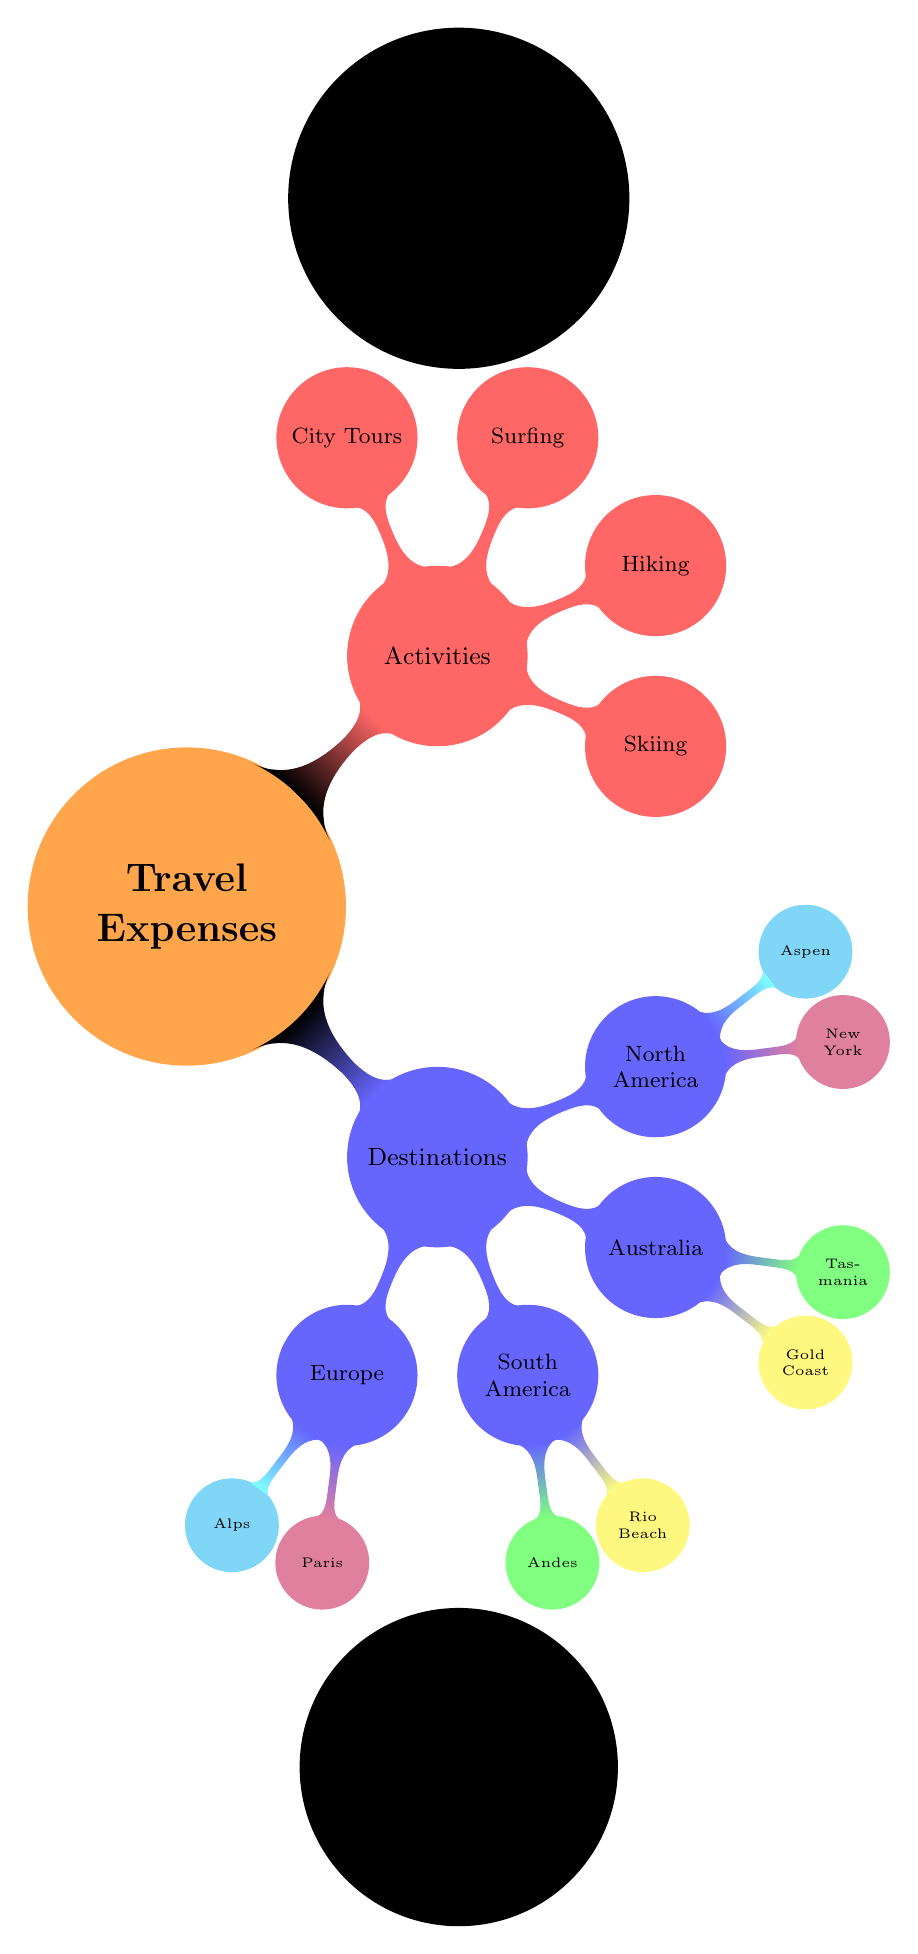What are the two main categories of travel expenses shown? The diagram directly lists the two main categories, which are "Destinations" and "Activities," prominently displayed branching from the central concept of "Travel Expenses."
Answer: Destinations, Activities How many destinations are included in the diagram? By counting the branches under "Destinations," we note that there are four main destinations: Europe, South America, Australia, and North America.
Answer: 4 What destination showcases a city known for romance? The diagram shows "Paris" as a child node under "Europe." Paris is widely recognized as a romantic city, making it the answer to this question.
Answer: Paris Which activity is associated with winter sports? The activity "Skiing" is displayed as one of the child nodes under "Activities" and is commonly associated with winter sports, including skiing resorts and snowy locations.
Answer: Skiing Which two destinations include the concept of beaches? The diagram lists "Rio Beach" under South America and "Gold Coast" under Australia, both of which are known for their beach locations.
Answer: Rio Beach, Gold Coast How many activities are listed in the diagram? There are four distinct activities categorized under "Activities": Skiing, Hiking, Surfing, and City Tours. Counting them provides the answer.
Answer: 4 Which destination is associated with comedy scouting trips? The diagram does not explicitly mention comedy scouting trips, but destinations like "New York" are popular for comedy, especially in performance arts, suggesting this area would be relevant for this context.
Answer: New York Identify the destination in the Southern Hemisphere. Among the listed destinations, "Australia," which includes the nodes "Gold Coast" and "Tasmania," is located in the Southern Hemisphere.
Answer: Australia What is the activity most likely associated with urban exploration? "City Tours" is explicitly mentioned as one of the activities in the diagram, which aligns with the concept of urban exploration.
Answer: City Tours 